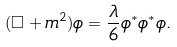Convert formula to latex. <formula><loc_0><loc_0><loc_500><loc_500>( \square + m ^ { 2 } ) \phi = \frac { \lambda } { 6 } \phi ^ { * } \phi ^ { * } \phi .</formula> 